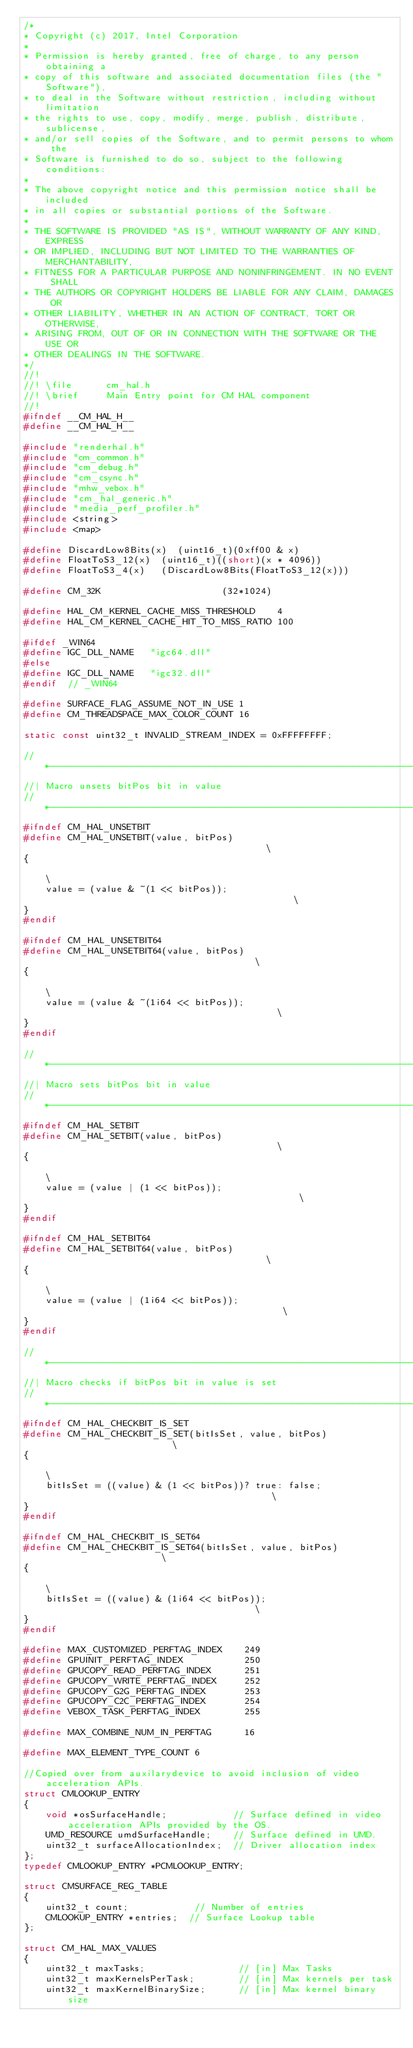<code> <loc_0><loc_0><loc_500><loc_500><_C_>/*
* Copyright (c) 2017, Intel Corporation
*
* Permission is hereby granted, free of charge, to any person obtaining a
* copy of this software and associated documentation files (the "Software"),
* to deal in the Software without restriction, including without limitation
* the rights to use, copy, modify, merge, publish, distribute, sublicense,
* and/or sell copies of the Software, and to permit persons to whom the
* Software is furnished to do so, subject to the following conditions:
*
* The above copyright notice and this permission notice shall be included
* in all copies or substantial portions of the Software.
*
* THE SOFTWARE IS PROVIDED "AS IS", WITHOUT WARRANTY OF ANY KIND, EXPRESS
* OR IMPLIED, INCLUDING BUT NOT LIMITED TO THE WARRANTIES OF MERCHANTABILITY,
* FITNESS FOR A PARTICULAR PURPOSE AND NONINFRINGEMENT. IN NO EVENT SHALL
* THE AUTHORS OR COPYRIGHT HOLDERS BE LIABLE FOR ANY CLAIM, DAMAGES OR
* OTHER LIABILITY, WHETHER IN AN ACTION OF CONTRACT, TORT OR OTHERWISE,
* ARISING FROM, OUT OF OR IN CONNECTION WITH THE SOFTWARE OR THE USE OR
* OTHER DEALINGS IN THE SOFTWARE.
*/
//!
//! \file      cm_hal.h 
//! \brief     Main Entry point for CM HAL component 
//!
#ifndef __CM_HAL_H__
#define __CM_HAL_H__

#include "renderhal.h"
#include "cm_common.h"
#include "cm_debug.h"
#include "cm_csync.h"
#include "mhw_vebox.h"
#include "cm_hal_generic.h"
#include "media_perf_profiler.h"
#include <string>
#include <map>

#define DiscardLow8Bits(x)  (uint16_t)(0xff00 & x)
#define FloatToS3_12(x)  (uint16_t)((short)(x * 4096))
#define FloatToS3_4(x)   (DiscardLow8Bits(FloatToS3_12(x)))

#define CM_32K                      (32*1024)

#define HAL_CM_KERNEL_CACHE_MISS_THRESHOLD    4
#define HAL_CM_KERNEL_CACHE_HIT_TO_MISS_RATIO 100

#ifdef _WIN64
#define IGC_DLL_NAME   "igc64.dll"
#else
#define IGC_DLL_NAME   "igc32.dll"
#endif  // _WIN64

#define SURFACE_FLAG_ASSUME_NOT_IN_USE 1
#define CM_THREADSPACE_MAX_COLOR_COUNT 16

static const uint32_t INVALID_STREAM_INDEX = 0xFFFFFFFF;

//*-----------------------------------------------------------------------------
//| Macro unsets bitPos bit in value
//*-----------------------------------------------------------------------------
#ifndef CM_HAL_UNSETBIT
#define CM_HAL_UNSETBIT(value, bitPos)                                         \
{                                                                              \
    value = (value & ~(1 << bitPos));                                          \
}
#endif

#ifndef CM_HAL_UNSETBIT64
#define CM_HAL_UNSETBIT64(value, bitPos)                                       \
{                                                                              \
    value = (value & ~(1i64 << bitPos));                                       \
}
#endif

//*-----------------------------------------------------------------------------
//| Macro sets bitPos bit in value
//*-----------------------------------------------------------------------------
#ifndef CM_HAL_SETBIT
#define CM_HAL_SETBIT(value, bitPos)                                           \
{                                                                              \
    value = (value | (1 << bitPos));                                           \
}
#endif

#ifndef CM_HAL_SETBIT64
#define CM_HAL_SETBIT64(value, bitPos)                                         \
{                                                                              \
    value = (value | (1i64 << bitPos));                                        \
}
#endif

//*-----------------------------------------------------------------------------
//| Macro checks if bitPos bit in value is set
//*-----------------------------------------------------------------------------
#ifndef CM_HAL_CHECKBIT_IS_SET
#define CM_HAL_CHECKBIT_IS_SET(bitIsSet, value, bitPos)                        \
{                                                                              \
    bitIsSet = ((value) & (1 << bitPos))? true: false;                                      \
}
#endif

#ifndef CM_HAL_CHECKBIT_IS_SET64
#define CM_HAL_CHECKBIT_IS_SET64(bitIsSet, value, bitPos)                      \
{                                                                              \
    bitIsSet = ((value) & (1i64 << bitPos));                                   \
}
#endif

#define MAX_CUSTOMIZED_PERFTAG_INDEX    249
#define GPUINIT_PERFTAG_INDEX           250
#define GPUCOPY_READ_PERFTAG_INDEX      251
#define GPUCOPY_WRITE_PERFTAG_INDEX     252
#define GPUCOPY_G2G_PERFTAG_INDEX       253
#define GPUCOPY_C2C_PERFTAG_INDEX       254
#define VEBOX_TASK_PERFTAG_INDEX        255

#define MAX_COMBINE_NUM_IN_PERFTAG      16

#define MAX_ELEMENT_TYPE_COUNT 6

//Copied over from auxilarydevice to avoid inclusion of video acceleration APIs.
struct CMLOOKUP_ENTRY
{
    void *osSurfaceHandle;            // Surface defined in video acceleration APIs provided by the OS.
    UMD_RESOURCE umdSurfaceHandle;    // Surface defined in UMD.
    uint32_t surfaceAllocationIndex;  // Driver allocation index
};
typedef CMLOOKUP_ENTRY *PCMLOOKUP_ENTRY;

struct CMSURFACE_REG_TABLE
{
    uint32_t count;            // Number of entries
    CMLOOKUP_ENTRY *entries;  // Surface Lookup table
};

struct CM_HAL_MAX_VALUES
{
    uint32_t maxTasks;                 // [in] Max Tasks
    uint32_t maxKernelsPerTask;        // [in] Max kernels per task
    uint32_t maxKernelBinarySize;      // [in] Max kernel binary size</code> 